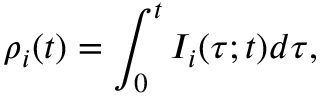Convert formula to latex. <formula><loc_0><loc_0><loc_500><loc_500>\rho _ { i } ( t ) = \int _ { 0 } ^ { t } I _ { i } ( \tau ; t ) d \tau ,</formula> 